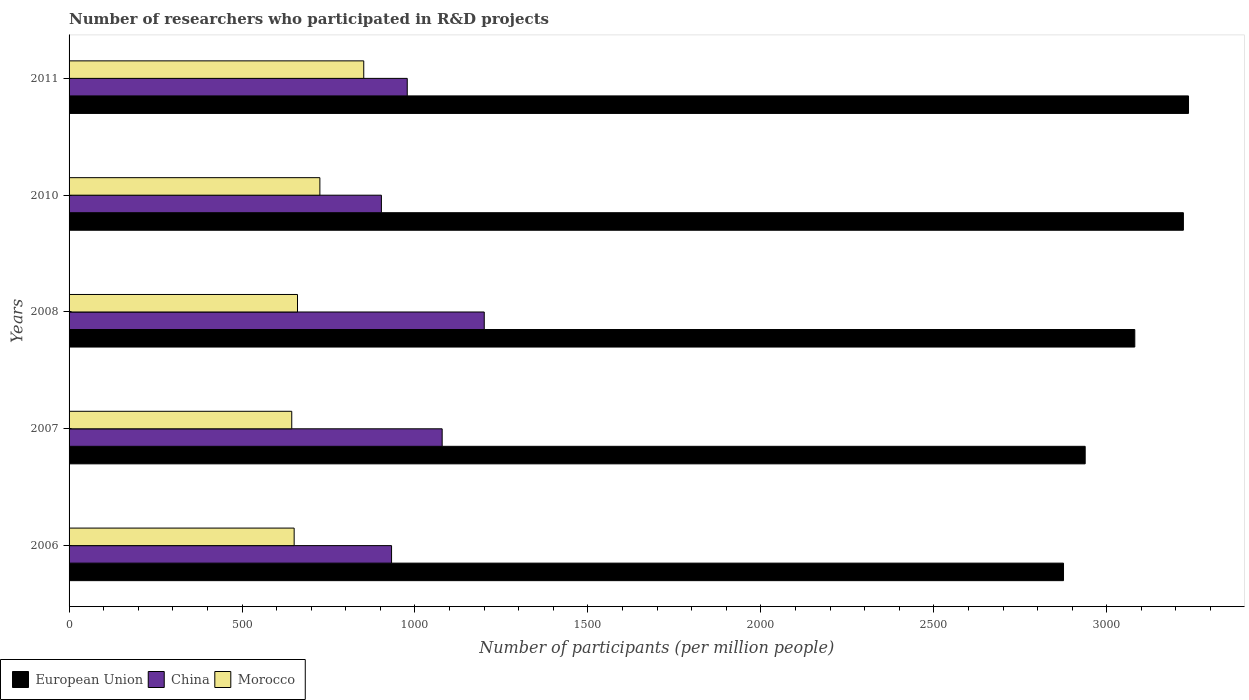How many different coloured bars are there?
Provide a succinct answer. 3. How many groups of bars are there?
Your response must be concise. 5. Are the number of bars per tick equal to the number of legend labels?
Keep it short and to the point. Yes. Are the number of bars on each tick of the Y-axis equal?
Your response must be concise. Yes. What is the label of the 1st group of bars from the top?
Your response must be concise. 2011. What is the number of researchers who participated in R&D projects in European Union in 2006?
Provide a succinct answer. 2874.94. Across all years, what is the maximum number of researchers who participated in R&D projects in China?
Make the answer very short. 1200.29. Across all years, what is the minimum number of researchers who participated in R&D projects in Morocco?
Provide a short and direct response. 643.76. What is the total number of researchers who participated in R&D projects in European Union in the graph?
Provide a succinct answer. 1.54e+04. What is the difference between the number of researchers who participated in R&D projects in China in 2007 and that in 2008?
Provide a succinct answer. -121.67. What is the difference between the number of researchers who participated in R&D projects in China in 2011 and the number of researchers who participated in R&D projects in European Union in 2008?
Your response must be concise. -2103.33. What is the average number of researchers who participated in R&D projects in China per year?
Offer a terse response. 1018.38. In the year 2011, what is the difference between the number of researchers who participated in R&D projects in European Union and number of researchers who participated in R&D projects in Morocco?
Provide a succinct answer. 2384.45. In how many years, is the number of researchers who participated in R&D projects in China greater than 2000 ?
Your response must be concise. 0. What is the ratio of the number of researchers who participated in R&D projects in European Union in 2007 to that in 2011?
Offer a very short reply. 0.91. Is the number of researchers who participated in R&D projects in China in 2006 less than that in 2011?
Provide a short and direct response. Yes. What is the difference between the highest and the second highest number of researchers who participated in R&D projects in Morocco?
Your answer should be very brief. 126.84. What is the difference between the highest and the lowest number of researchers who participated in R&D projects in European Union?
Give a very brief answer. 361.41. In how many years, is the number of researchers who participated in R&D projects in China greater than the average number of researchers who participated in R&D projects in China taken over all years?
Give a very brief answer. 2. What does the 1st bar from the top in 2008 represents?
Offer a very short reply. Morocco. How many bars are there?
Your answer should be very brief. 15. Are all the bars in the graph horizontal?
Provide a short and direct response. Yes. Does the graph contain grids?
Provide a short and direct response. No. How are the legend labels stacked?
Ensure brevity in your answer.  Horizontal. What is the title of the graph?
Give a very brief answer. Number of researchers who participated in R&D projects. Does "St. Vincent and the Grenadines" appear as one of the legend labels in the graph?
Give a very brief answer. No. What is the label or title of the X-axis?
Keep it short and to the point. Number of participants (per million people). What is the Number of participants (per million people) of European Union in 2006?
Provide a succinct answer. 2874.94. What is the Number of participants (per million people) of China in 2006?
Offer a very short reply. 932.31. What is the Number of participants (per million people) of Morocco in 2006?
Offer a very short reply. 650.74. What is the Number of participants (per million people) of European Union in 2007?
Provide a succinct answer. 2937.59. What is the Number of participants (per million people) of China in 2007?
Your answer should be compact. 1078.63. What is the Number of participants (per million people) of Morocco in 2007?
Your answer should be compact. 643.76. What is the Number of participants (per million people) in European Union in 2008?
Your answer should be compact. 3081.01. What is the Number of participants (per million people) of China in 2008?
Your answer should be compact. 1200.29. What is the Number of participants (per million people) in Morocco in 2008?
Offer a very short reply. 660.37. What is the Number of participants (per million people) of European Union in 2010?
Make the answer very short. 3221.54. What is the Number of participants (per million people) in China in 2010?
Make the answer very short. 902.96. What is the Number of participants (per million people) in Morocco in 2010?
Provide a short and direct response. 725.06. What is the Number of participants (per million people) of European Union in 2011?
Your answer should be compact. 3236.35. What is the Number of participants (per million people) in China in 2011?
Your response must be concise. 977.68. What is the Number of participants (per million people) in Morocco in 2011?
Give a very brief answer. 851.9. Across all years, what is the maximum Number of participants (per million people) in European Union?
Your answer should be very brief. 3236.35. Across all years, what is the maximum Number of participants (per million people) of China?
Give a very brief answer. 1200.29. Across all years, what is the maximum Number of participants (per million people) in Morocco?
Make the answer very short. 851.9. Across all years, what is the minimum Number of participants (per million people) of European Union?
Ensure brevity in your answer.  2874.94. Across all years, what is the minimum Number of participants (per million people) of China?
Ensure brevity in your answer.  902.96. Across all years, what is the minimum Number of participants (per million people) in Morocco?
Ensure brevity in your answer.  643.76. What is the total Number of participants (per million people) in European Union in the graph?
Provide a succinct answer. 1.54e+04. What is the total Number of participants (per million people) in China in the graph?
Your response must be concise. 5091.88. What is the total Number of participants (per million people) in Morocco in the graph?
Offer a very short reply. 3531.83. What is the difference between the Number of participants (per million people) of European Union in 2006 and that in 2007?
Keep it short and to the point. -62.65. What is the difference between the Number of participants (per million people) of China in 2006 and that in 2007?
Ensure brevity in your answer.  -146.31. What is the difference between the Number of participants (per million people) of Morocco in 2006 and that in 2007?
Offer a very short reply. 6.97. What is the difference between the Number of participants (per million people) of European Union in 2006 and that in 2008?
Make the answer very short. -206.07. What is the difference between the Number of participants (per million people) in China in 2006 and that in 2008?
Make the answer very short. -267.98. What is the difference between the Number of participants (per million people) of Morocco in 2006 and that in 2008?
Your answer should be compact. -9.64. What is the difference between the Number of participants (per million people) of European Union in 2006 and that in 2010?
Your response must be concise. -346.6. What is the difference between the Number of participants (per million people) in China in 2006 and that in 2010?
Your answer should be very brief. 29.35. What is the difference between the Number of participants (per million people) in Morocco in 2006 and that in 2010?
Your response must be concise. -74.32. What is the difference between the Number of participants (per million people) in European Union in 2006 and that in 2011?
Your answer should be compact. -361.41. What is the difference between the Number of participants (per million people) in China in 2006 and that in 2011?
Ensure brevity in your answer.  -45.37. What is the difference between the Number of participants (per million people) of Morocco in 2006 and that in 2011?
Offer a terse response. -201.17. What is the difference between the Number of participants (per million people) in European Union in 2007 and that in 2008?
Your response must be concise. -143.42. What is the difference between the Number of participants (per million people) of China in 2007 and that in 2008?
Offer a very short reply. -121.67. What is the difference between the Number of participants (per million people) in Morocco in 2007 and that in 2008?
Keep it short and to the point. -16.61. What is the difference between the Number of participants (per million people) in European Union in 2007 and that in 2010?
Offer a terse response. -283.95. What is the difference between the Number of participants (per million people) in China in 2007 and that in 2010?
Ensure brevity in your answer.  175.67. What is the difference between the Number of participants (per million people) of Morocco in 2007 and that in 2010?
Offer a very short reply. -81.29. What is the difference between the Number of participants (per million people) in European Union in 2007 and that in 2011?
Ensure brevity in your answer.  -298.76. What is the difference between the Number of participants (per million people) of China in 2007 and that in 2011?
Give a very brief answer. 100.94. What is the difference between the Number of participants (per million people) of Morocco in 2007 and that in 2011?
Offer a very short reply. -208.14. What is the difference between the Number of participants (per million people) of European Union in 2008 and that in 2010?
Provide a short and direct response. -140.53. What is the difference between the Number of participants (per million people) in China in 2008 and that in 2010?
Offer a very short reply. 297.34. What is the difference between the Number of participants (per million people) in Morocco in 2008 and that in 2010?
Provide a succinct answer. -64.69. What is the difference between the Number of participants (per million people) of European Union in 2008 and that in 2011?
Offer a very short reply. -155.33. What is the difference between the Number of participants (per million people) of China in 2008 and that in 2011?
Make the answer very short. 222.61. What is the difference between the Number of participants (per million people) of Morocco in 2008 and that in 2011?
Provide a short and direct response. -191.53. What is the difference between the Number of participants (per million people) of European Union in 2010 and that in 2011?
Offer a terse response. -14.81. What is the difference between the Number of participants (per million people) of China in 2010 and that in 2011?
Ensure brevity in your answer.  -74.72. What is the difference between the Number of participants (per million people) of Morocco in 2010 and that in 2011?
Give a very brief answer. -126.84. What is the difference between the Number of participants (per million people) of European Union in 2006 and the Number of participants (per million people) of China in 2007?
Provide a succinct answer. 1796.31. What is the difference between the Number of participants (per million people) of European Union in 2006 and the Number of participants (per million people) of Morocco in 2007?
Offer a very short reply. 2231.18. What is the difference between the Number of participants (per million people) of China in 2006 and the Number of participants (per million people) of Morocco in 2007?
Give a very brief answer. 288.55. What is the difference between the Number of participants (per million people) of European Union in 2006 and the Number of participants (per million people) of China in 2008?
Offer a terse response. 1674.65. What is the difference between the Number of participants (per million people) in European Union in 2006 and the Number of participants (per million people) in Morocco in 2008?
Your answer should be compact. 2214.57. What is the difference between the Number of participants (per million people) of China in 2006 and the Number of participants (per million people) of Morocco in 2008?
Your answer should be compact. 271.94. What is the difference between the Number of participants (per million people) in European Union in 2006 and the Number of participants (per million people) in China in 2010?
Give a very brief answer. 1971.98. What is the difference between the Number of participants (per million people) of European Union in 2006 and the Number of participants (per million people) of Morocco in 2010?
Provide a short and direct response. 2149.88. What is the difference between the Number of participants (per million people) of China in 2006 and the Number of participants (per million people) of Morocco in 2010?
Provide a succinct answer. 207.26. What is the difference between the Number of participants (per million people) of European Union in 2006 and the Number of participants (per million people) of China in 2011?
Your answer should be very brief. 1897.26. What is the difference between the Number of participants (per million people) in European Union in 2006 and the Number of participants (per million people) in Morocco in 2011?
Ensure brevity in your answer.  2023.04. What is the difference between the Number of participants (per million people) in China in 2006 and the Number of participants (per million people) in Morocco in 2011?
Offer a terse response. 80.41. What is the difference between the Number of participants (per million people) of European Union in 2007 and the Number of participants (per million people) of China in 2008?
Offer a very short reply. 1737.29. What is the difference between the Number of participants (per million people) in European Union in 2007 and the Number of participants (per million people) in Morocco in 2008?
Make the answer very short. 2277.22. What is the difference between the Number of participants (per million people) of China in 2007 and the Number of participants (per million people) of Morocco in 2008?
Make the answer very short. 418.25. What is the difference between the Number of participants (per million people) of European Union in 2007 and the Number of participants (per million people) of China in 2010?
Provide a succinct answer. 2034.63. What is the difference between the Number of participants (per million people) in European Union in 2007 and the Number of participants (per million people) in Morocco in 2010?
Ensure brevity in your answer.  2212.53. What is the difference between the Number of participants (per million people) in China in 2007 and the Number of participants (per million people) in Morocco in 2010?
Your response must be concise. 353.57. What is the difference between the Number of participants (per million people) in European Union in 2007 and the Number of participants (per million people) in China in 2011?
Offer a very short reply. 1959.91. What is the difference between the Number of participants (per million people) of European Union in 2007 and the Number of participants (per million people) of Morocco in 2011?
Offer a terse response. 2085.69. What is the difference between the Number of participants (per million people) of China in 2007 and the Number of participants (per million people) of Morocco in 2011?
Your answer should be compact. 226.72. What is the difference between the Number of participants (per million people) of European Union in 2008 and the Number of participants (per million people) of China in 2010?
Your answer should be very brief. 2178.05. What is the difference between the Number of participants (per million people) in European Union in 2008 and the Number of participants (per million people) in Morocco in 2010?
Make the answer very short. 2355.95. What is the difference between the Number of participants (per million people) of China in 2008 and the Number of participants (per million people) of Morocco in 2010?
Offer a very short reply. 475.24. What is the difference between the Number of participants (per million people) of European Union in 2008 and the Number of participants (per million people) of China in 2011?
Your response must be concise. 2103.33. What is the difference between the Number of participants (per million people) in European Union in 2008 and the Number of participants (per million people) in Morocco in 2011?
Keep it short and to the point. 2229.11. What is the difference between the Number of participants (per million people) of China in 2008 and the Number of participants (per million people) of Morocco in 2011?
Provide a short and direct response. 348.39. What is the difference between the Number of participants (per million people) in European Union in 2010 and the Number of participants (per million people) in China in 2011?
Offer a very short reply. 2243.86. What is the difference between the Number of participants (per million people) in European Union in 2010 and the Number of participants (per million people) in Morocco in 2011?
Give a very brief answer. 2369.64. What is the difference between the Number of participants (per million people) in China in 2010 and the Number of participants (per million people) in Morocco in 2011?
Your answer should be very brief. 51.06. What is the average Number of participants (per million people) in European Union per year?
Make the answer very short. 3070.29. What is the average Number of participants (per million people) of China per year?
Your answer should be very brief. 1018.38. What is the average Number of participants (per million people) of Morocco per year?
Provide a short and direct response. 706.37. In the year 2006, what is the difference between the Number of participants (per million people) of European Union and Number of participants (per million people) of China?
Make the answer very short. 1942.63. In the year 2006, what is the difference between the Number of participants (per million people) of European Union and Number of participants (per million people) of Morocco?
Ensure brevity in your answer.  2224.2. In the year 2006, what is the difference between the Number of participants (per million people) in China and Number of participants (per million people) in Morocco?
Keep it short and to the point. 281.58. In the year 2007, what is the difference between the Number of participants (per million people) of European Union and Number of participants (per million people) of China?
Your answer should be very brief. 1858.96. In the year 2007, what is the difference between the Number of participants (per million people) of European Union and Number of participants (per million people) of Morocco?
Make the answer very short. 2293.82. In the year 2007, what is the difference between the Number of participants (per million people) in China and Number of participants (per million people) in Morocco?
Offer a terse response. 434.86. In the year 2008, what is the difference between the Number of participants (per million people) in European Union and Number of participants (per million people) in China?
Your answer should be compact. 1880.72. In the year 2008, what is the difference between the Number of participants (per million people) of European Union and Number of participants (per million people) of Morocco?
Your answer should be very brief. 2420.64. In the year 2008, what is the difference between the Number of participants (per million people) in China and Number of participants (per million people) in Morocco?
Your answer should be compact. 539.92. In the year 2010, what is the difference between the Number of participants (per million people) of European Union and Number of participants (per million people) of China?
Make the answer very short. 2318.58. In the year 2010, what is the difference between the Number of participants (per million people) of European Union and Number of participants (per million people) of Morocco?
Ensure brevity in your answer.  2496.48. In the year 2010, what is the difference between the Number of participants (per million people) in China and Number of participants (per million people) in Morocco?
Provide a succinct answer. 177.9. In the year 2011, what is the difference between the Number of participants (per million people) in European Union and Number of participants (per million people) in China?
Offer a terse response. 2258.66. In the year 2011, what is the difference between the Number of participants (per million people) of European Union and Number of participants (per million people) of Morocco?
Offer a terse response. 2384.45. In the year 2011, what is the difference between the Number of participants (per million people) in China and Number of participants (per million people) in Morocco?
Ensure brevity in your answer.  125.78. What is the ratio of the Number of participants (per million people) of European Union in 2006 to that in 2007?
Provide a succinct answer. 0.98. What is the ratio of the Number of participants (per million people) of China in 2006 to that in 2007?
Make the answer very short. 0.86. What is the ratio of the Number of participants (per million people) in Morocco in 2006 to that in 2007?
Make the answer very short. 1.01. What is the ratio of the Number of participants (per million people) in European Union in 2006 to that in 2008?
Give a very brief answer. 0.93. What is the ratio of the Number of participants (per million people) in China in 2006 to that in 2008?
Ensure brevity in your answer.  0.78. What is the ratio of the Number of participants (per million people) of Morocco in 2006 to that in 2008?
Provide a succinct answer. 0.99. What is the ratio of the Number of participants (per million people) in European Union in 2006 to that in 2010?
Your answer should be compact. 0.89. What is the ratio of the Number of participants (per million people) of China in 2006 to that in 2010?
Provide a short and direct response. 1.03. What is the ratio of the Number of participants (per million people) in Morocco in 2006 to that in 2010?
Your answer should be very brief. 0.9. What is the ratio of the Number of participants (per million people) of European Union in 2006 to that in 2011?
Provide a succinct answer. 0.89. What is the ratio of the Number of participants (per million people) of China in 2006 to that in 2011?
Your answer should be compact. 0.95. What is the ratio of the Number of participants (per million people) in Morocco in 2006 to that in 2011?
Make the answer very short. 0.76. What is the ratio of the Number of participants (per million people) in European Union in 2007 to that in 2008?
Offer a very short reply. 0.95. What is the ratio of the Number of participants (per million people) of China in 2007 to that in 2008?
Provide a short and direct response. 0.9. What is the ratio of the Number of participants (per million people) of Morocco in 2007 to that in 2008?
Make the answer very short. 0.97. What is the ratio of the Number of participants (per million people) in European Union in 2007 to that in 2010?
Ensure brevity in your answer.  0.91. What is the ratio of the Number of participants (per million people) in China in 2007 to that in 2010?
Offer a terse response. 1.19. What is the ratio of the Number of participants (per million people) of Morocco in 2007 to that in 2010?
Provide a short and direct response. 0.89. What is the ratio of the Number of participants (per million people) in European Union in 2007 to that in 2011?
Give a very brief answer. 0.91. What is the ratio of the Number of participants (per million people) in China in 2007 to that in 2011?
Offer a terse response. 1.1. What is the ratio of the Number of participants (per million people) of Morocco in 2007 to that in 2011?
Ensure brevity in your answer.  0.76. What is the ratio of the Number of participants (per million people) of European Union in 2008 to that in 2010?
Keep it short and to the point. 0.96. What is the ratio of the Number of participants (per million people) in China in 2008 to that in 2010?
Provide a short and direct response. 1.33. What is the ratio of the Number of participants (per million people) in Morocco in 2008 to that in 2010?
Provide a succinct answer. 0.91. What is the ratio of the Number of participants (per million people) of China in 2008 to that in 2011?
Provide a short and direct response. 1.23. What is the ratio of the Number of participants (per million people) of Morocco in 2008 to that in 2011?
Ensure brevity in your answer.  0.78. What is the ratio of the Number of participants (per million people) of European Union in 2010 to that in 2011?
Your response must be concise. 1. What is the ratio of the Number of participants (per million people) of China in 2010 to that in 2011?
Your answer should be compact. 0.92. What is the ratio of the Number of participants (per million people) in Morocco in 2010 to that in 2011?
Your answer should be very brief. 0.85. What is the difference between the highest and the second highest Number of participants (per million people) of European Union?
Give a very brief answer. 14.81. What is the difference between the highest and the second highest Number of participants (per million people) in China?
Your answer should be very brief. 121.67. What is the difference between the highest and the second highest Number of participants (per million people) in Morocco?
Provide a short and direct response. 126.84. What is the difference between the highest and the lowest Number of participants (per million people) in European Union?
Keep it short and to the point. 361.41. What is the difference between the highest and the lowest Number of participants (per million people) in China?
Your answer should be compact. 297.34. What is the difference between the highest and the lowest Number of participants (per million people) in Morocco?
Give a very brief answer. 208.14. 